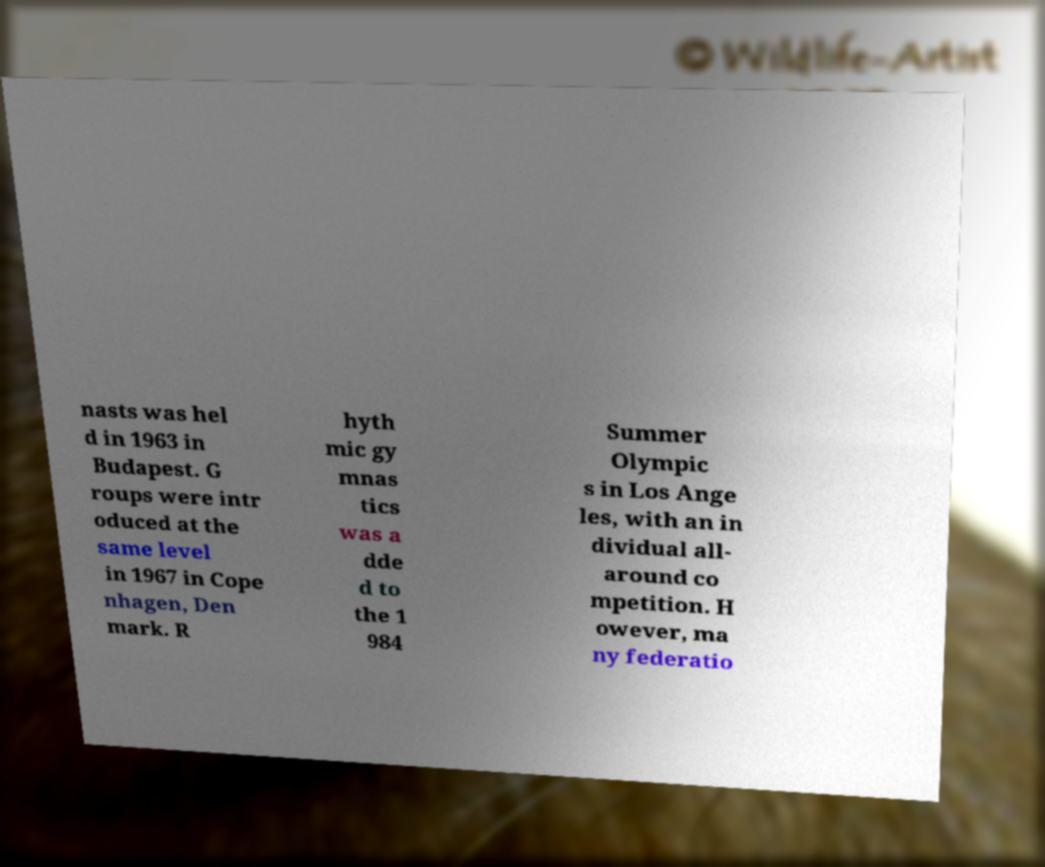Please identify and transcribe the text found in this image. nasts was hel d in 1963 in Budapest. G roups were intr oduced at the same level in 1967 in Cope nhagen, Den mark. R hyth mic gy mnas tics was a dde d to the 1 984 Summer Olympic s in Los Ange les, with an in dividual all- around co mpetition. H owever, ma ny federatio 